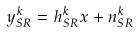Convert formula to latex. <formula><loc_0><loc_0><loc_500><loc_500>y _ { S R } ^ { k } = h _ { S R } ^ { k } x + n _ { S R } ^ { k }</formula> 